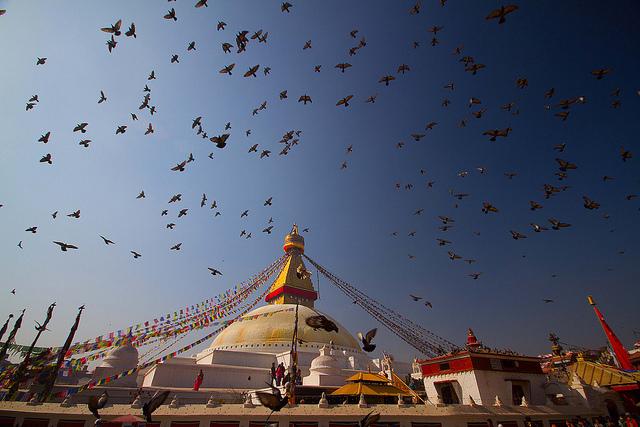What is in the sky?
Write a very short answer. Birds. Can cumulus clouds be seen?
Answer briefly. No. Is this underwater?
Quick response, please. No. What movie does this resemble?
Quick response, please. Birds. 